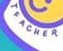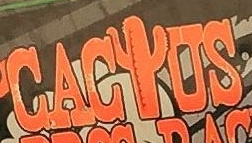Read the text content from these images in order, separated by a semicolon. TEACHER; CACIUS 